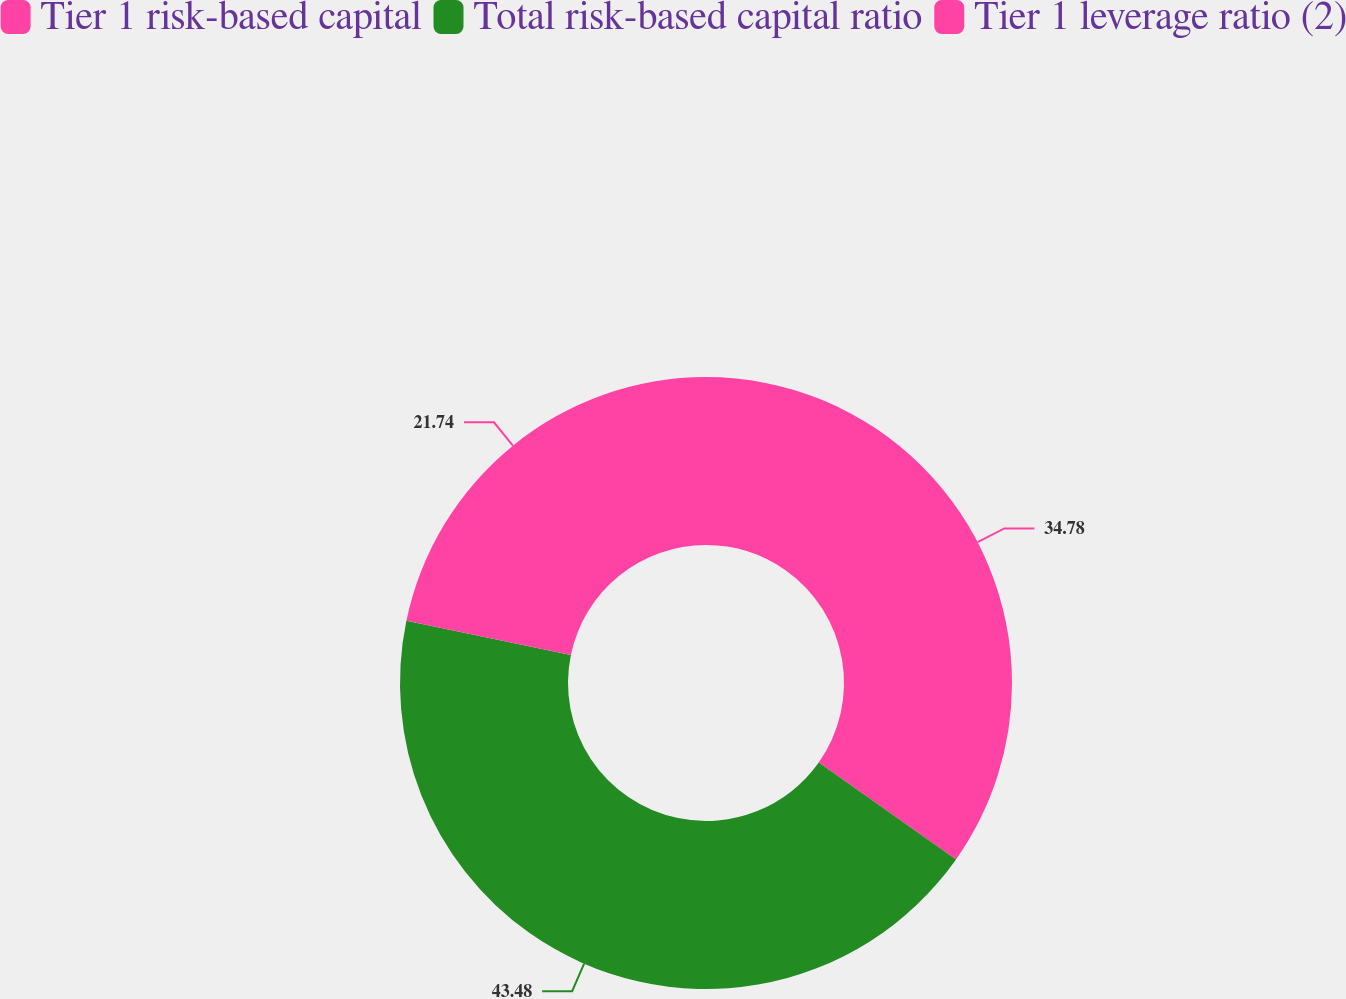Convert chart to OTSL. <chart><loc_0><loc_0><loc_500><loc_500><pie_chart><fcel>Tier 1 risk-based capital<fcel>Total risk-based capital ratio<fcel>Tier 1 leverage ratio (2)<nl><fcel>34.78%<fcel>43.48%<fcel>21.74%<nl></chart> 